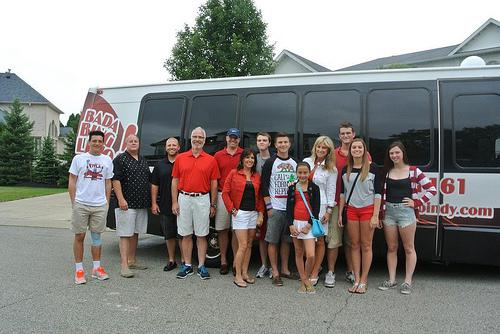Question: what is behind the group of people?
Choices:
A. Trees.
B. Bus.
C. A fair.
D. Cars.
Answer with the letter. Answer: B Question: how many males are there?
Choices:
A. 12.
B. 15.
C. 8.
D. 5.
Answer with the letter. Answer: C Question: what colors are the stripes on girl's jacket?
Choices:
A. Green and yellow.
B. Red and black.
C. Red and white.
D. Orange and black.
Answer with the letter. Answer: C Question: what color are the bus's windows?
Choices:
A. White.
B. Black.
C. Grey.
D. Blue.
Answer with the letter. Answer: B Question: who is wearing red shorts?
Choices:
A. Man in back.
B. Female in front.
C. Child to the right.
D. Girl to the left.
Answer with the letter. Answer: B Question: how many red shirts are there?
Choices:
A. 1.
B. 2.
C. 4.
D. 3.
Answer with the letter. Answer: C 